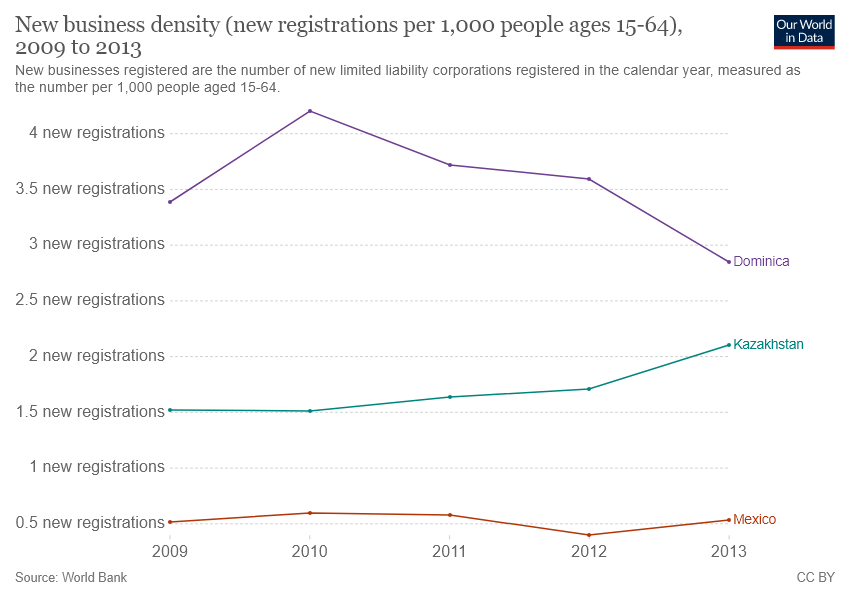Outline some significant characteristics in this image. Dominica has a higher business density over the years than Kazakhstan. In 2010, the business density in Dominica reached its highest level. 